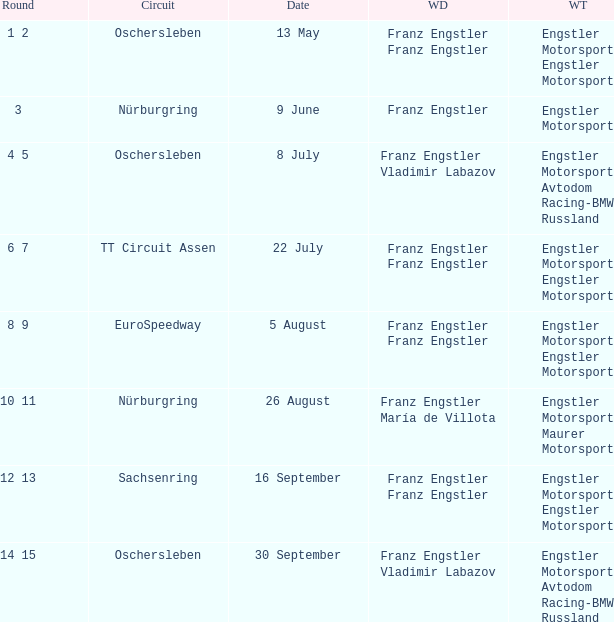Who is the Winning Driver that has a Winning team of Engstler Motorsport Engstler Motorsport and also the Date 22 July? Franz Engstler Franz Engstler. 